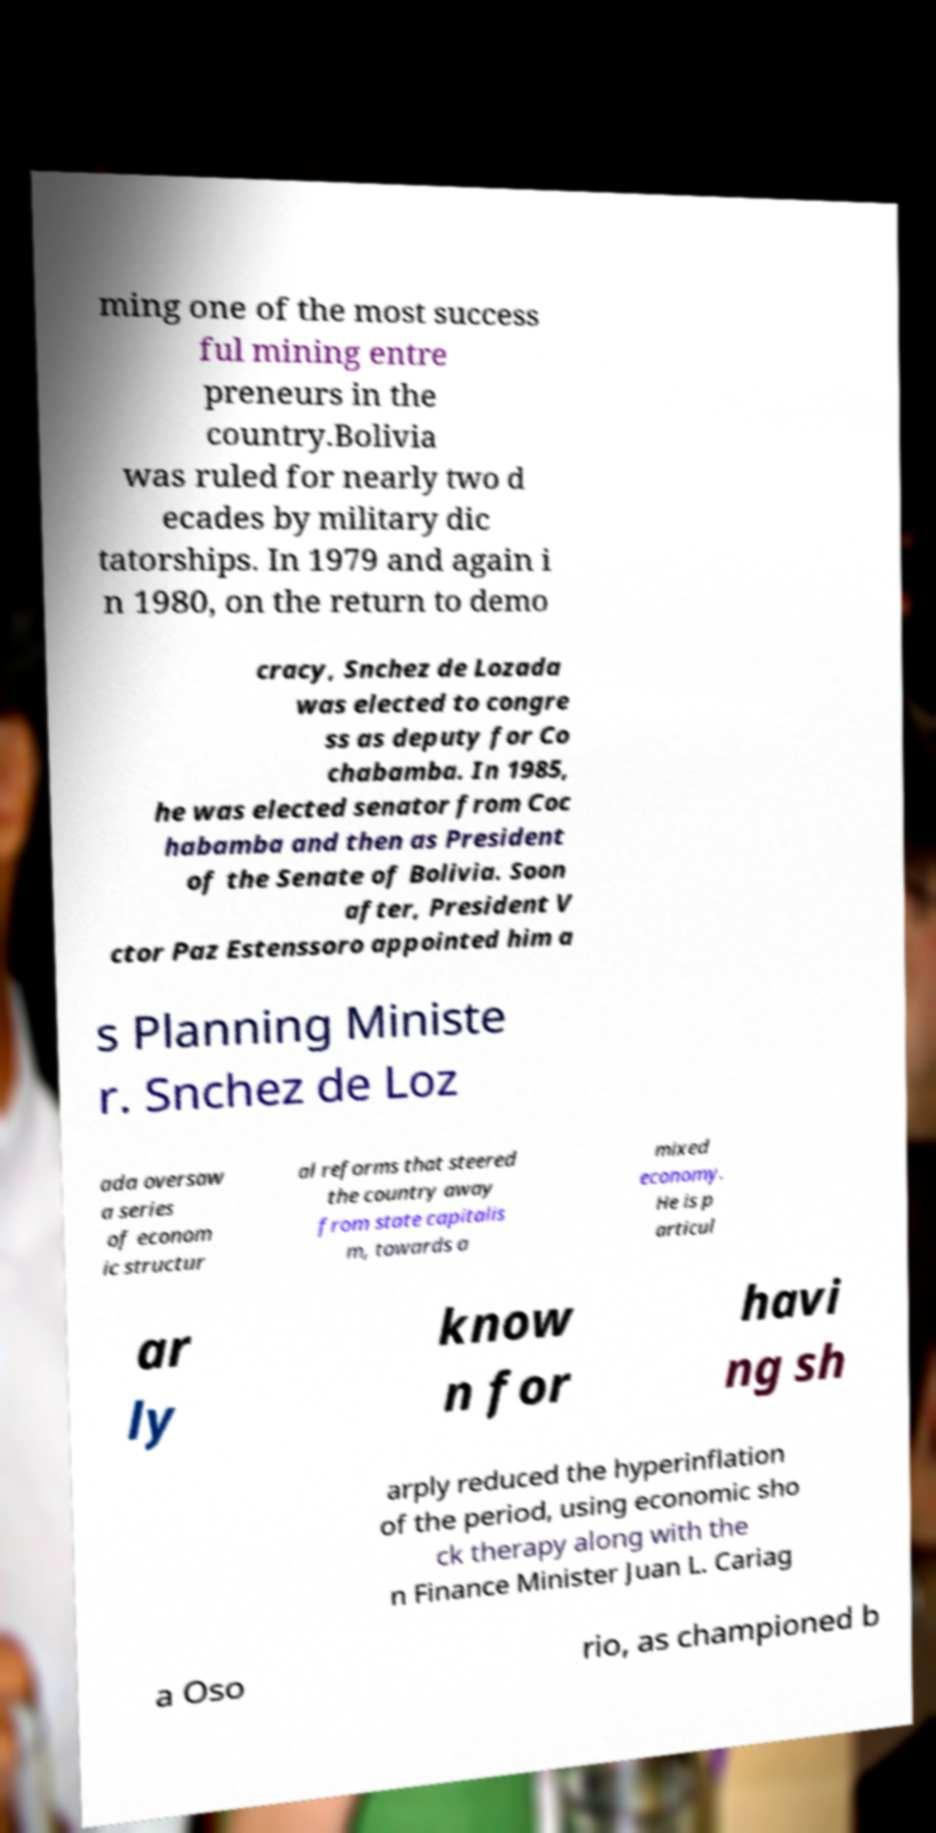Can you read and provide the text displayed in the image?This photo seems to have some interesting text. Can you extract and type it out for me? ming one of the most success ful mining entre preneurs in the country.Bolivia was ruled for nearly two d ecades by military dic tatorships. In 1979 and again i n 1980, on the return to demo cracy, Snchez de Lozada was elected to congre ss as deputy for Co chabamba. In 1985, he was elected senator from Coc habamba and then as President of the Senate of Bolivia. Soon after, President V ctor Paz Estenssoro appointed him a s Planning Ministe r. Snchez de Loz ada oversaw a series of econom ic structur al reforms that steered the country away from state capitalis m, towards a mixed economy. He is p articul ar ly know n for havi ng sh arply reduced the hyperinflation of the period, using economic sho ck therapy along with the n Finance Minister Juan L. Cariag a Oso rio, as championed b 